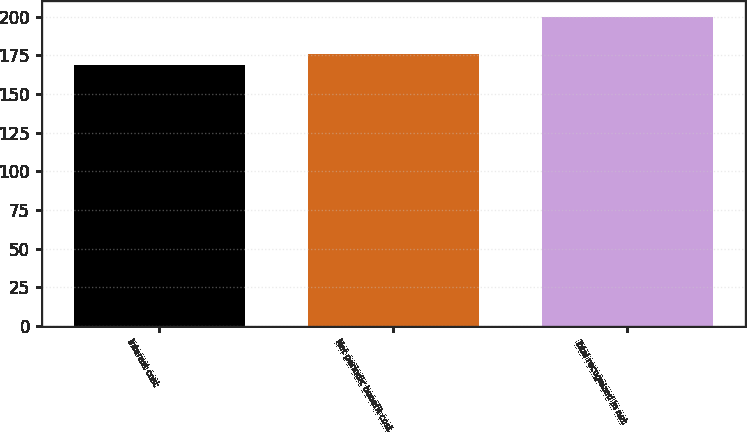<chart> <loc_0><loc_0><loc_500><loc_500><bar_chart><fcel>Interest cost<fcel>Net periodic benefit cost<fcel>Total recognized in net<nl><fcel>169<fcel>176<fcel>200<nl></chart> 